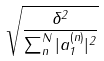Convert formula to latex. <formula><loc_0><loc_0><loc_500><loc_500>\sqrt { \frac { \delta ^ { 2 } } { \sum _ { n } ^ { N } | a _ { 1 } ^ { ( n ) } | ^ { 2 } } }</formula> 